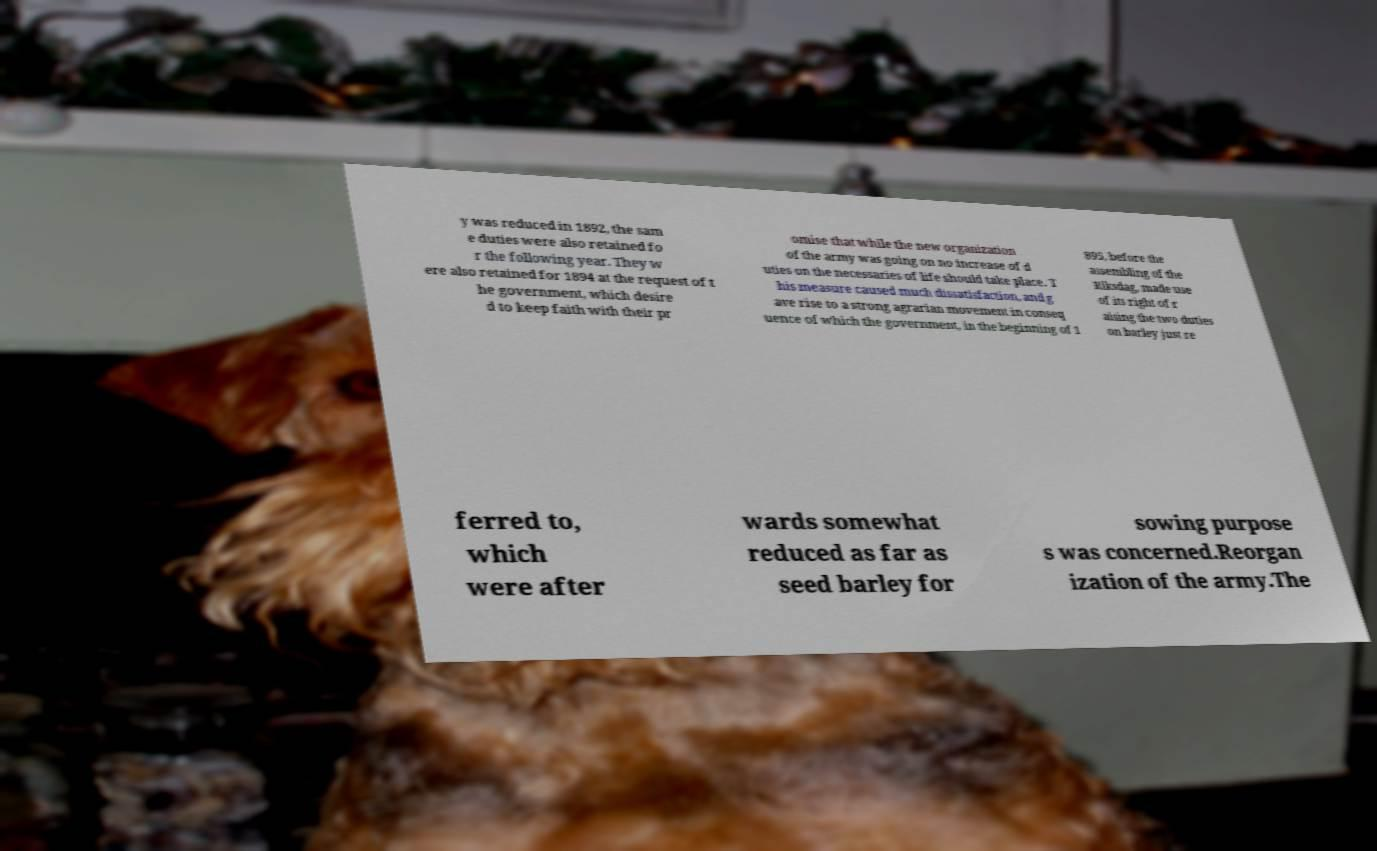Please read and relay the text visible in this image. What does it say? y was reduced in 1892, the sam e duties were also retained fo r the following year. They w ere also retained for 1894 at the request of t he government, which desire d to keep faith with their pr omise that while the new organization of the army was going on no increase of d uties on the necessaries of life should take place. T his measure caused much dissatisfaction, and g ave rise to a strong agrarian movement in conseq uence of which the government, in the beginning of 1 895, before the assembling of the Riksdag, made use of its right of r aising the two duties on barley just re ferred to, which were after wards somewhat reduced as far as seed barley for sowing purpose s was concerned.Reorgan ization of the army.The 